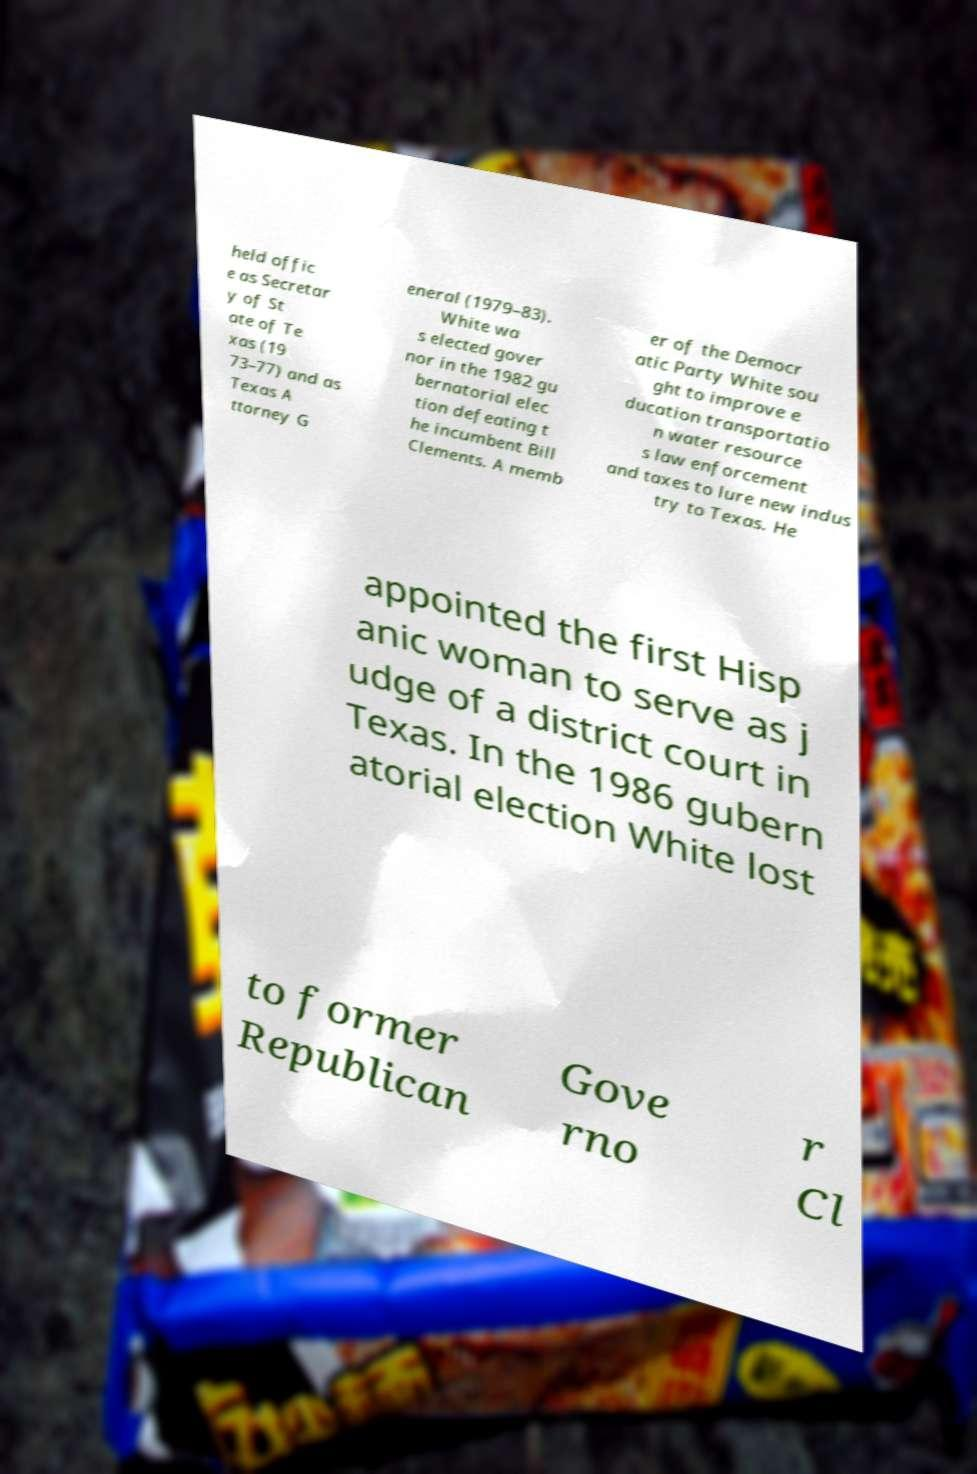Please read and relay the text visible in this image. What does it say? held offic e as Secretar y of St ate of Te xas (19 73–77) and as Texas A ttorney G eneral (1979–83). White wa s elected gover nor in the 1982 gu bernatorial elec tion defeating t he incumbent Bill Clements. A memb er of the Democr atic Party White sou ght to improve e ducation transportatio n water resource s law enforcement and taxes to lure new indus try to Texas. He appointed the first Hisp anic woman to serve as j udge of a district court in Texas. In the 1986 gubern atorial election White lost to former Republican Gove rno r Cl 